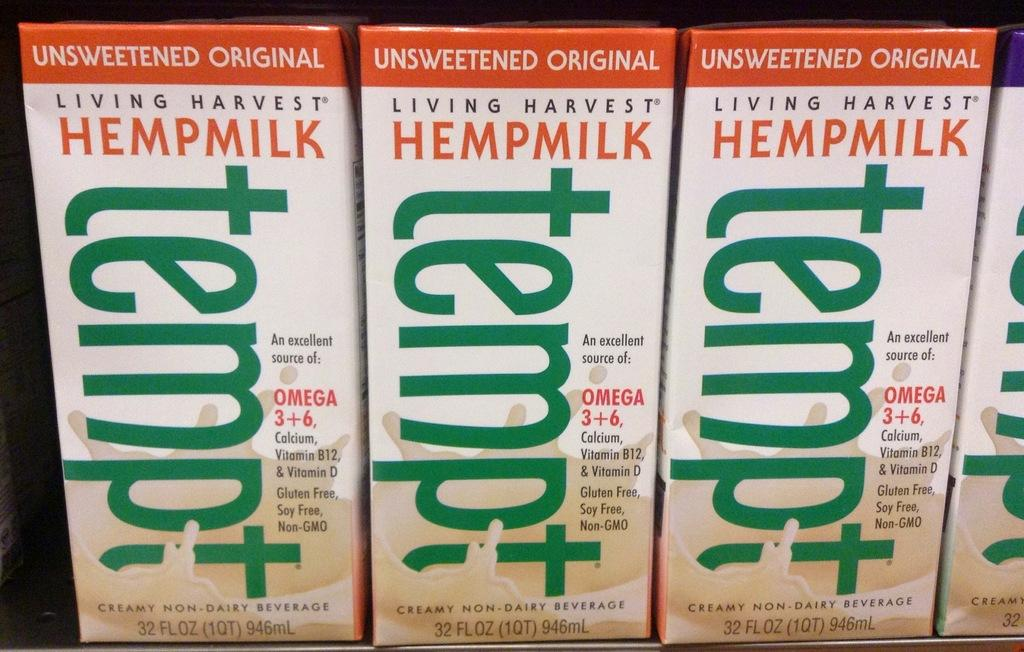<image>
Describe the image concisely. 3 containers of unsweetened orginal living harvest hempmilk 